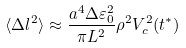<formula> <loc_0><loc_0><loc_500><loc_500>\langle \Delta l ^ { 2 } \rangle \approx \frac { a ^ { 4 } \Delta \varepsilon _ { 0 } ^ { 2 } } { \pi L ^ { 2 } } \rho ^ { 2 } V _ { c } ^ { 2 } ( t ^ { * } )</formula> 